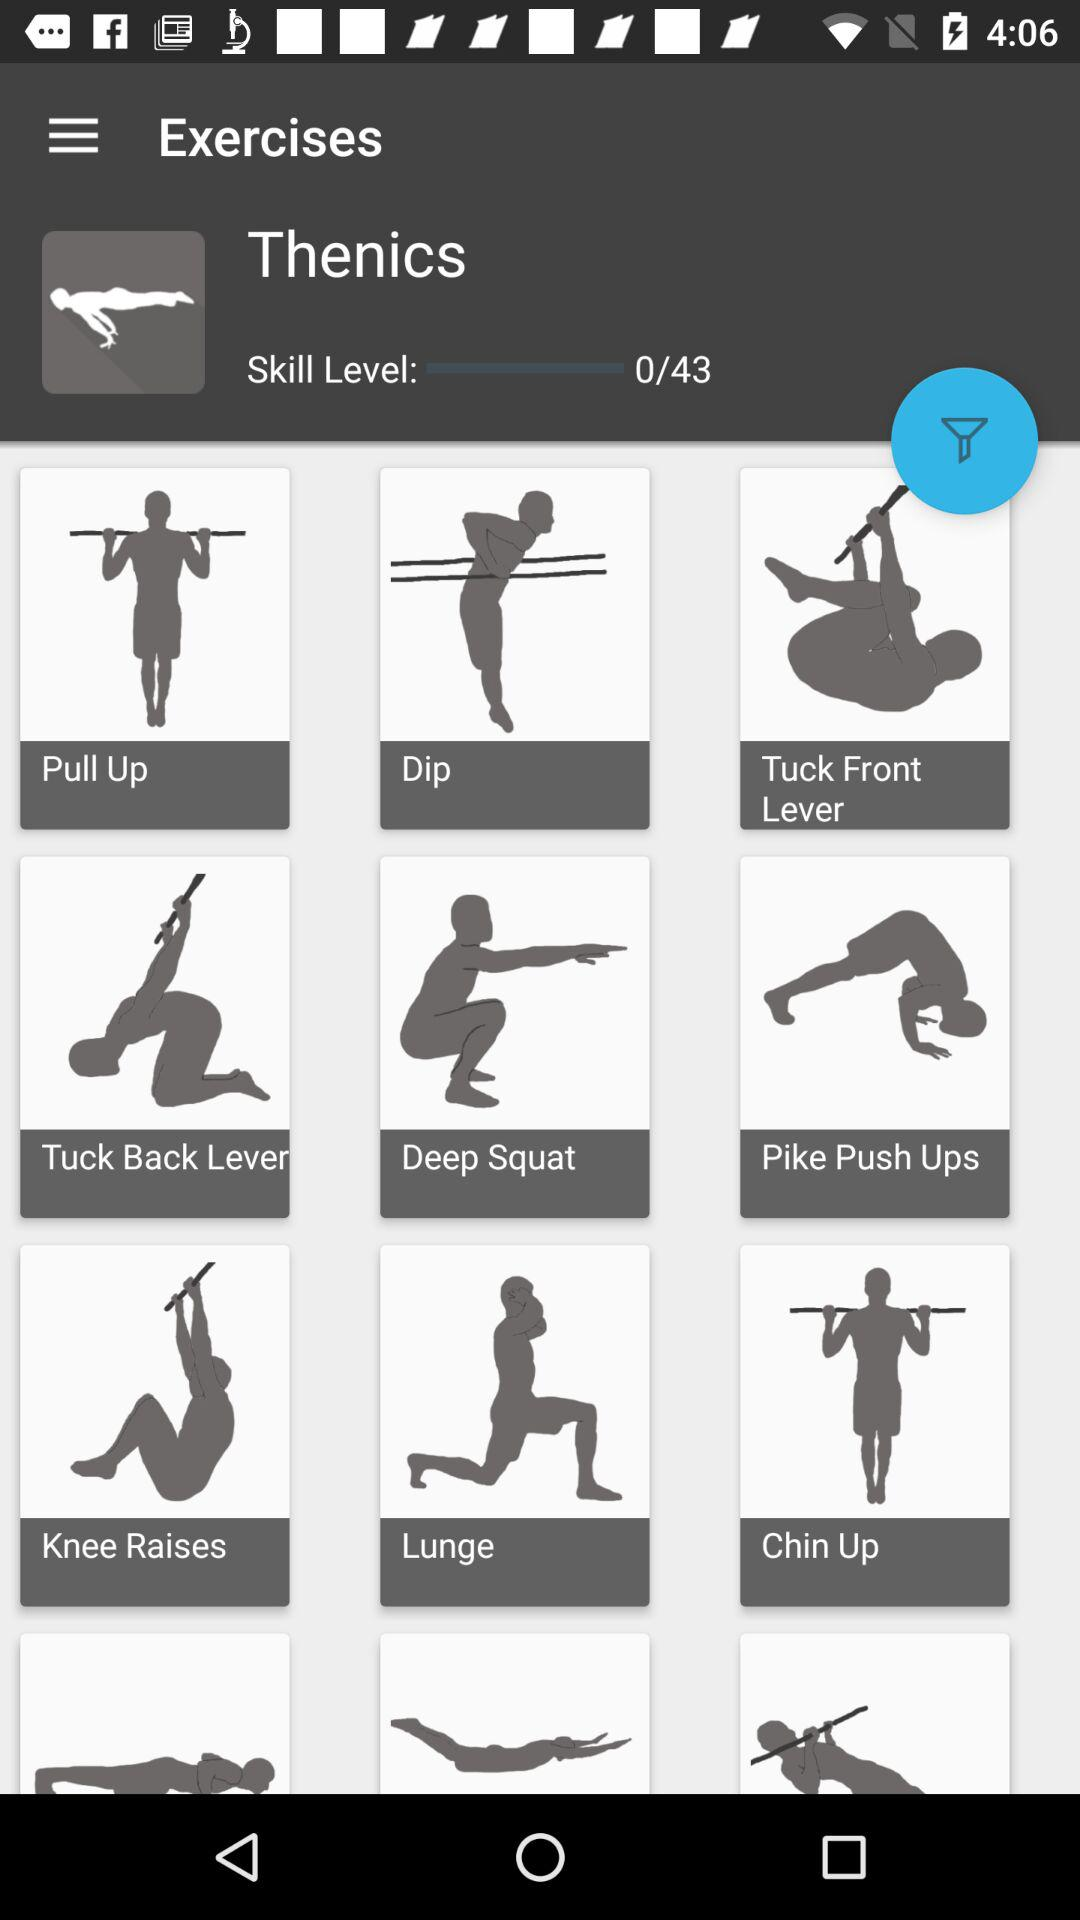Which are the different exercises? The different exercises are "Pull Up", "Dip", "Tuck Front Lever", "Tuck Back Lever", "Deep Squat", "Pike Push Ups", "Knee Raises", "Lunge" and "Chin Up". 